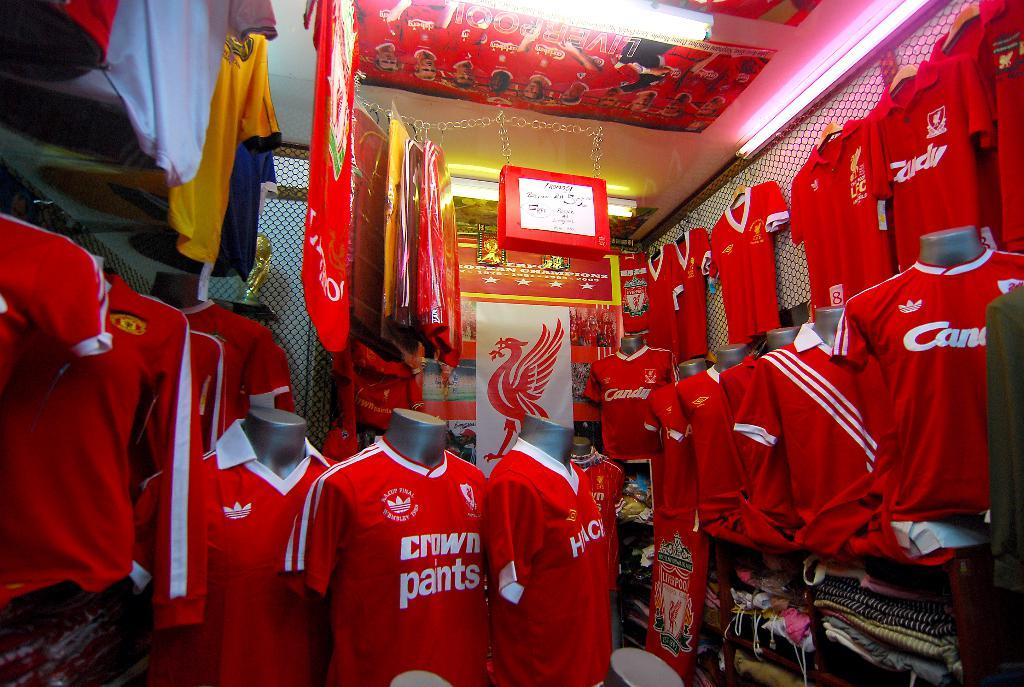<image>
Render a clear and concise summary of the photo. the word pants that are on some shirts 